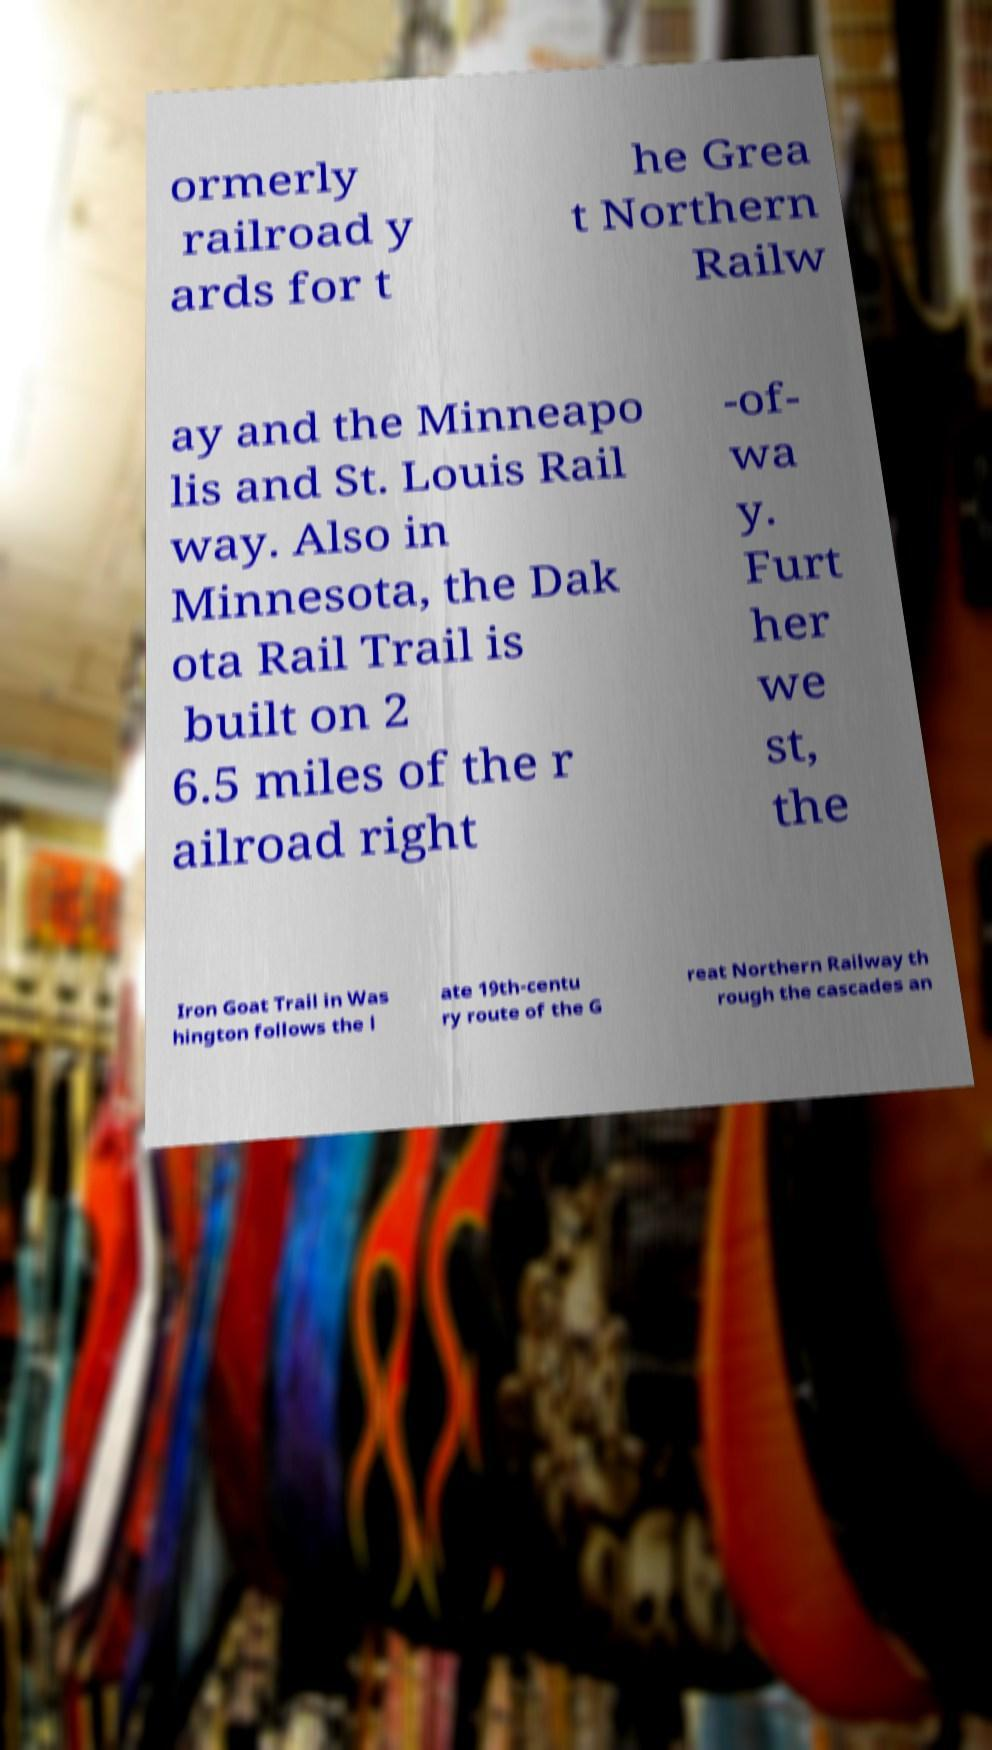Can you accurately transcribe the text from the provided image for me? ormerly railroad y ards for t he Grea t Northern Railw ay and the Minneapo lis and St. Louis Rail way. Also in Minnesota, the Dak ota Rail Trail is built on 2 6.5 miles of the r ailroad right -of- wa y. Furt her we st, the Iron Goat Trail in Was hington follows the l ate 19th-centu ry route of the G reat Northern Railway th rough the cascades an 